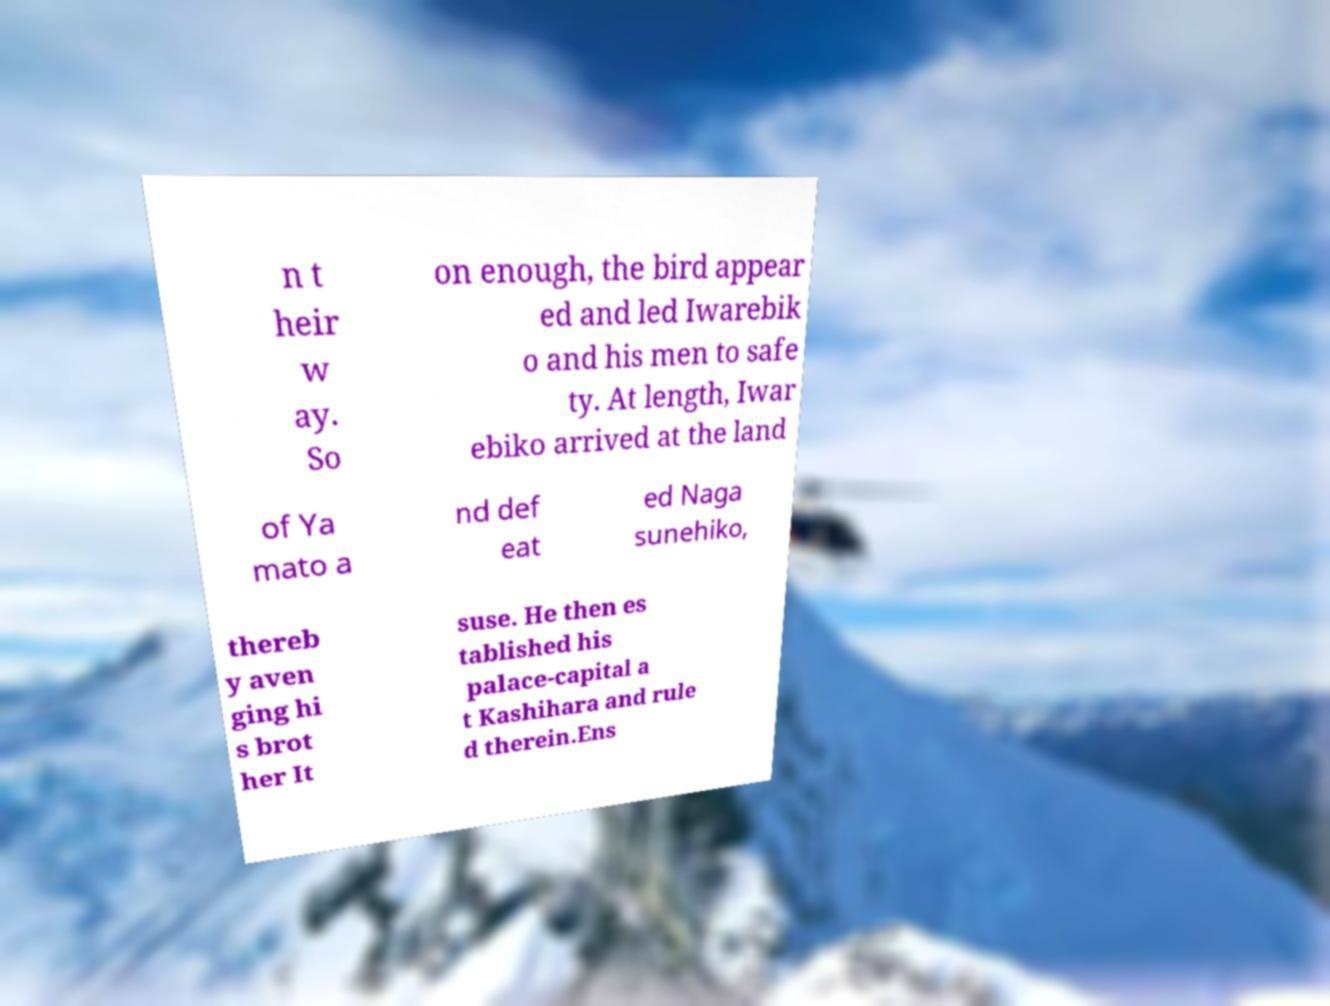I need the written content from this picture converted into text. Can you do that? n t heir w ay. So on enough, the bird appear ed and led Iwarebik o and his men to safe ty. At length, Iwar ebiko arrived at the land of Ya mato a nd def eat ed Naga sunehiko, thereb y aven ging hi s brot her It suse. He then es tablished his palace-capital a t Kashihara and rule d therein.Ens 